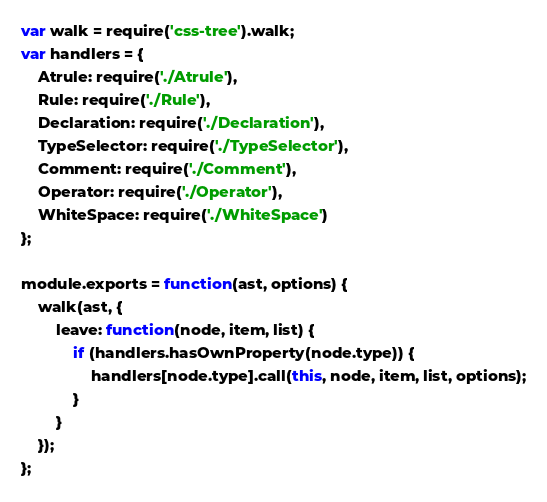<code> <loc_0><loc_0><loc_500><loc_500><_JavaScript_>var walk = require('css-tree').walk;
var handlers = {
    Atrule: require('./Atrule'),
    Rule: require('./Rule'),
    Declaration: require('./Declaration'),
    TypeSelector: require('./TypeSelector'),
    Comment: require('./Comment'),
    Operator: require('./Operator'),
    WhiteSpace: require('./WhiteSpace')
};

module.exports = function(ast, options) {
    walk(ast, {
        leave: function(node, item, list) {
            if (handlers.hasOwnProperty(node.type)) {
                handlers[node.type].call(this, node, item, list, options);
            }
        }
    });
};
</code> 